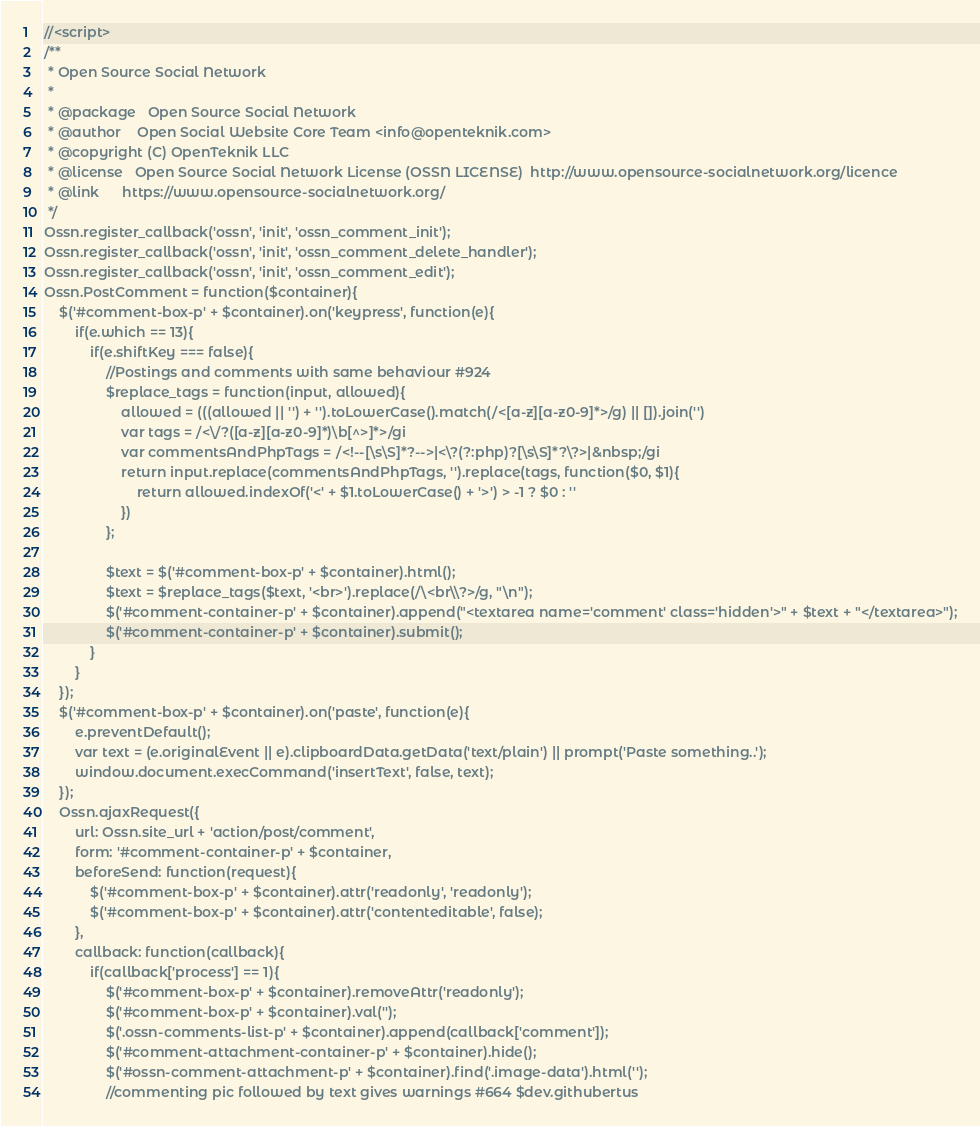Convert code to text. <code><loc_0><loc_0><loc_500><loc_500><_PHP_>//<script>
/**
 * Open Source Social Network
 *
 * @package   Open Source Social Network
 * @author    Open Social Website Core Team <info@openteknik.com>
 * @copyright (C) OpenTeknik LLC
 * @license   Open Source Social Network License (OSSN LICENSE)  http://www.opensource-socialnetwork.org/licence
 * @link      https://www.opensource-socialnetwork.org/
 */
Ossn.register_callback('ossn', 'init', 'ossn_comment_init');
Ossn.register_callback('ossn', 'init', 'ossn_comment_delete_handler');
Ossn.register_callback('ossn', 'init', 'ossn_comment_edit');
Ossn.PostComment = function($container){
	$('#comment-box-p' + $container).on('keypress', function(e){
		if(e.which == 13){
			if(e.shiftKey === false){
				//Postings and comments with same behaviour #924
				$replace_tags = function(input, allowed){
					allowed = (((allowed || '') + '').toLowerCase().match(/<[a-z][a-z0-9]*>/g) || []).join('')
					var tags = /<\/?([a-z][a-z0-9]*)\b[^>]*>/gi
					var commentsAndPhpTags = /<!--[\s\S]*?-->|<\?(?:php)?[\s\S]*?\?>|&nbsp;/gi
					return input.replace(commentsAndPhpTags, '').replace(tags, function($0, $1){
						return allowed.indexOf('<' + $1.toLowerCase() + '>') > -1 ? $0 : ''
					})
				};

				$text = $('#comment-box-p' + $container).html();
				$text = $replace_tags($text, '<br>').replace(/\<br\\?>/g, "\n");
				$('#comment-container-p' + $container).append("<textarea name='comment' class='hidden'>" + $text + "</textarea>");
				$('#comment-container-p' + $container).submit();
			}
		}
	});
	$('#comment-box-p' + $container).on('paste', function(e){
		e.preventDefault();
		var text = (e.originalEvent || e).clipboardData.getData('text/plain') || prompt('Paste something..');
		window.document.execCommand('insertText', false, text);
	});
	Ossn.ajaxRequest({
		url: Ossn.site_url + 'action/post/comment',
		form: '#comment-container-p' + $container,
		beforeSend: function(request){
			$('#comment-box-p' + $container).attr('readonly', 'readonly');
			$('#comment-box-p' + $container).attr('contenteditable', false);
		},
		callback: function(callback){
			if(callback['process'] == 1){
				$('#comment-box-p' + $container).removeAttr('readonly');
				$('#comment-box-p' + $container).val('');
				$('.ossn-comments-list-p' + $container).append(callback['comment']);
				$('#comment-attachment-container-p' + $container).hide();
				$('#ossn-comment-attachment-p' + $container).find('.image-data').html('');
				//commenting pic followed by text gives warnings #664 $dev.githubertus</code> 